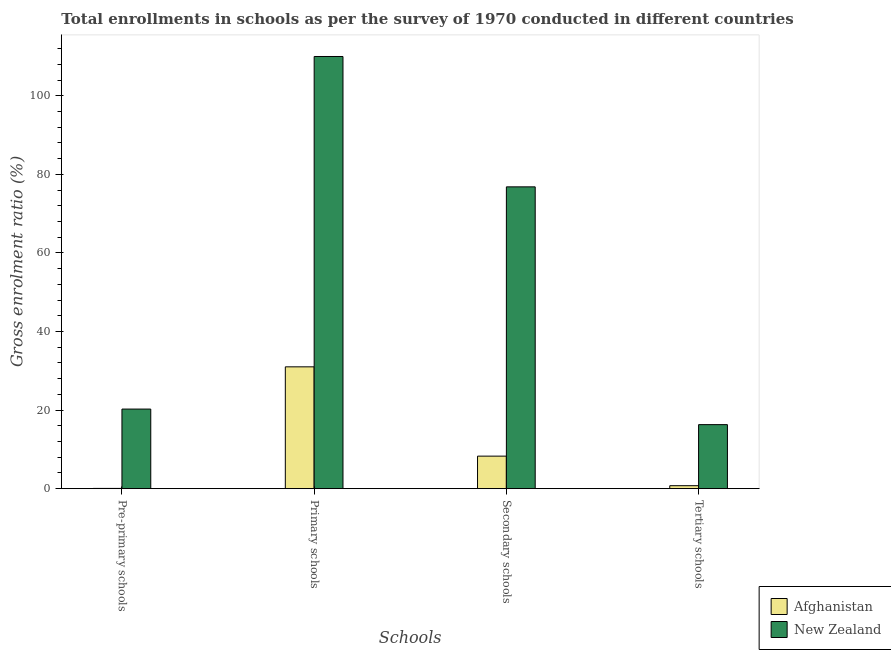How many groups of bars are there?
Make the answer very short. 4. How many bars are there on the 3rd tick from the right?
Provide a succinct answer. 2. What is the label of the 4th group of bars from the left?
Make the answer very short. Tertiary schools. What is the gross enrolment ratio in tertiary schools in Afghanistan?
Provide a succinct answer. 0.76. Across all countries, what is the maximum gross enrolment ratio in primary schools?
Your answer should be very brief. 110.01. Across all countries, what is the minimum gross enrolment ratio in pre-primary schools?
Provide a succinct answer. 0.07. In which country was the gross enrolment ratio in secondary schools maximum?
Keep it short and to the point. New Zealand. In which country was the gross enrolment ratio in secondary schools minimum?
Give a very brief answer. Afghanistan. What is the total gross enrolment ratio in tertiary schools in the graph?
Offer a very short reply. 17.06. What is the difference between the gross enrolment ratio in primary schools in New Zealand and that in Afghanistan?
Offer a very short reply. 79. What is the difference between the gross enrolment ratio in secondary schools in New Zealand and the gross enrolment ratio in pre-primary schools in Afghanistan?
Offer a very short reply. 76.76. What is the average gross enrolment ratio in pre-primary schools per country?
Your answer should be very brief. 10.17. What is the difference between the gross enrolment ratio in secondary schools and gross enrolment ratio in primary schools in Afghanistan?
Your answer should be compact. -22.73. In how many countries, is the gross enrolment ratio in tertiary schools greater than 48 %?
Make the answer very short. 0. What is the ratio of the gross enrolment ratio in pre-primary schools in Afghanistan to that in New Zealand?
Give a very brief answer. 0. Is the gross enrolment ratio in pre-primary schools in Afghanistan less than that in New Zealand?
Make the answer very short. Yes. What is the difference between the highest and the second highest gross enrolment ratio in primary schools?
Make the answer very short. 79. What is the difference between the highest and the lowest gross enrolment ratio in secondary schools?
Offer a terse response. 68.54. In how many countries, is the gross enrolment ratio in tertiary schools greater than the average gross enrolment ratio in tertiary schools taken over all countries?
Offer a terse response. 1. Is the sum of the gross enrolment ratio in tertiary schools in New Zealand and Afghanistan greater than the maximum gross enrolment ratio in primary schools across all countries?
Provide a short and direct response. No. Is it the case that in every country, the sum of the gross enrolment ratio in secondary schools and gross enrolment ratio in pre-primary schools is greater than the sum of gross enrolment ratio in primary schools and gross enrolment ratio in tertiary schools?
Your answer should be compact. No. What does the 1st bar from the left in Pre-primary schools represents?
Make the answer very short. Afghanistan. What does the 2nd bar from the right in Secondary schools represents?
Your answer should be very brief. Afghanistan. Is it the case that in every country, the sum of the gross enrolment ratio in pre-primary schools and gross enrolment ratio in primary schools is greater than the gross enrolment ratio in secondary schools?
Your response must be concise. Yes. How many bars are there?
Give a very brief answer. 8. How many countries are there in the graph?
Give a very brief answer. 2. What is the difference between two consecutive major ticks on the Y-axis?
Your response must be concise. 20. Are the values on the major ticks of Y-axis written in scientific E-notation?
Provide a short and direct response. No. How are the legend labels stacked?
Your answer should be compact. Vertical. What is the title of the graph?
Your answer should be very brief. Total enrollments in schools as per the survey of 1970 conducted in different countries. What is the label or title of the X-axis?
Offer a terse response. Schools. What is the Gross enrolment ratio (%) in Afghanistan in Pre-primary schools?
Offer a very short reply. 0.07. What is the Gross enrolment ratio (%) in New Zealand in Pre-primary schools?
Make the answer very short. 20.26. What is the Gross enrolment ratio (%) in Afghanistan in Primary schools?
Offer a terse response. 31.01. What is the Gross enrolment ratio (%) in New Zealand in Primary schools?
Offer a very short reply. 110.01. What is the Gross enrolment ratio (%) in Afghanistan in Secondary schools?
Provide a succinct answer. 8.29. What is the Gross enrolment ratio (%) of New Zealand in Secondary schools?
Keep it short and to the point. 76.83. What is the Gross enrolment ratio (%) of Afghanistan in Tertiary schools?
Provide a succinct answer. 0.76. What is the Gross enrolment ratio (%) in New Zealand in Tertiary schools?
Your response must be concise. 16.3. Across all Schools, what is the maximum Gross enrolment ratio (%) of Afghanistan?
Give a very brief answer. 31.01. Across all Schools, what is the maximum Gross enrolment ratio (%) in New Zealand?
Give a very brief answer. 110.01. Across all Schools, what is the minimum Gross enrolment ratio (%) of Afghanistan?
Offer a very short reply. 0.07. Across all Schools, what is the minimum Gross enrolment ratio (%) of New Zealand?
Ensure brevity in your answer.  16.3. What is the total Gross enrolment ratio (%) in Afghanistan in the graph?
Give a very brief answer. 40.13. What is the total Gross enrolment ratio (%) in New Zealand in the graph?
Your response must be concise. 223.4. What is the difference between the Gross enrolment ratio (%) in Afghanistan in Pre-primary schools and that in Primary schools?
Provide a succinct answer. -30.95. What is the difference between the Gross enrolment ratio (%) in New Zealand in Pre-primary schools and that in Primary schools?
Keep it short and to the point. -89.75. What is the difference between the Gross enrolment ratio (%) of Afghanistan in Pre-primary schools and that in Secondary schools?
Offer a very short reply. -8.22. What is the difference between the Gross enrolment ratio (%) of New Zealand in Pre-primary schools and that in Secondary schools?
Your answer should be compact. -56.56. What is the difference between the Gross enrolment ratio (%) in Afghanistan in Pre-primary schools and that in Tertiary schools?
Make the answer very short. -0.69. What is the difference between the Gross enrolment ratio (%) of New Zealand in Pre-primary schools and that in Tertiary schools?
Provide a short and direct response. 3.96. What is the difference between the Gross enrolment ratio (%) in Afghanistan in Primary schools and that in Secondary schools?
Your response must be concise. 22.73. What is the difference between the Gross enrolment ratio (%) in New Zealand in Primary schools and that in Secondary schools?
Your response must be concise. 33.18. What is the difference between the Gross enrolment ratio (%) of Afghanistan in Primary schools and that in Tertiary schools?
Offer a very short reply. 30.26. What is the difference between the Gross enrolment ratio (%) of New Zealand in Primary schools and that in Tertiary schools?
Provide a succinct answer. 93.71. What is the difference between the Gross enrolment ratio (%) in Afghanistan in Secondary schools and that in Tertiary schools?
Ensure brevity in your answer.  7.53. What is the difference between the Gross enrolment ratio (%) in New Zealand in Secondary schools and that in Tertiary schools?
Ensure brevity in your answer.  60.53. What is the difference between the Gross enrolment ratio (%) in Afghanistan in Pre-primary schools and the Gross enrolment ratio (%) in New Zealand in Primary schools?
Provide a succinct answer. -109.94. What is the difference between the Gross enrolment ratio (%) in Afghanistan in Pre-primary schools and the Gross enrolment ratio (%) in New Zealand in Secondary schools?
Ensure brevity in your answer.  -76.76. What is the difference between the Gross enrolment ratio (%) of Afghanistan in Pre-primary schools and the Gross enrolment ratio (%) of New Zealand in Tertiary schools?
Your response must be concise. -16.23. What is the difference between the Gross enrolment ratio (%) of Afghanistan in Primary schools and the Gross enrolment ratio (%) of New Zealand in Secondary schools?
Provide a succinct answer. -45.81. What is the difference between the Gross enrolment ratio (%) in Afghanistan in Primary schools and the Gross enrolment ratio (%) in New Zealand in Tertiary schools?
Provide a succinct answer. 14.71. What is the difference between the Gross enrolment ratio (%) of Afghanistan in Secondary schools and the Gross enrolment ratio (%) of New Zealand in Tertiary schools?
Your answer should be very brief. -8.02. What is the average Gross enrolment ratio (%) in Afghanistan per Schools?
Your answer should be compact. 10.03. What is the average Gross enrolment ratio (%) in New Zealand per Schools?
Keep it short and to the point. 55.85. What is the difference between the Gross enrolment ratio (%) in Afghanistan and Gross enrolment ratio (%) in New Zealand in Pre-primary schools?
Offer a terse response. -20.2. What is the difference between the Gross enrolment ratio (%) in Afghanistan and Gross enrolment ratio (%) in New Zealand in Primary schools?
Provide a succinct answer. -79. What is the difference between the Gross enrolment ratio (%) in Afghanistan and Gross enrolment ratio (%) in New Zealand in Secondary schools?
Ensure brevity in your answer.  -68.54. What is the difference between the Gross enrolment ratio (%) of Afghanistan and Gross enrolment ratio (%) of New Zealand in Tertiary schools?
Make the answer very short. -15.54. What is the ratio of the Gross enrolment ratio (%) of Afghanistan in Pre-primary schools to that in Primary schools?
Ensure brevity in your answer.  0. What is the ratio of the Gross enrolment ratio (%) of New Zealand in Pre-primary schools to that in Primary schools?
Offer a very short reply. 0.18. What is the ratio of the Gross enrolment ratio (%) of Afghanistan in Pre-primary schools to that in Secondary schools?
Your answer should be very brief. 0.01. What is the ratio of the Gross enrolment ratio (%) in New Zealand in Pre-primary schools to that in Secondary schools?
Offer a terse response. 0.26. What is the ratio of the Gross enrolment ratio (%) of Afghanistan in Pre-primary schools to that in Tertiary schools?
Give a very brief answer. 0.09. What is the ratio of the Gross enrolment ratio (%) in New Zealand in Pre-primary schools to that in Tertiary schools?
Give a very brief answer. 1.24. What is the ratio of the Gross enrolment ratio (%) in Afghanistan in Primary schools to that in Secondary schools?
Offer a very short reply. 3.74. What is the ratio of the Gross enrolment ratio (%) in New Zealand in Primary schools to that in Secondary schools?
Provide a succinct answer. 1.43. What is the ratio of the Gross enrolment ratio (%) in Afghanistan in Primary schools to that in Tertiary schools?
Your answer should be very brief. 40.94. What is the ratio of the Gross enrolment ratio (%) of New Zealand in Primary schools to that in Tertiary schools?
Offer a very short reply. 6.75. What is the ratio of the Gross enrolment ratio (%) of Afghanistan in Secondary schools to that in Tertiary schools?
Offer a very short reply. 10.94. What is the ratio of the Gross enrolment ratio (%) of New Zealand in Secondary schools to that in Tertiary schools?
Your answer should be compact. 4.71. What is the difference between the highest and the second highest Gross enrolment ratio (%) of Afghanistan?
Provide a succinct answer. 22.73. What is the difference between the highest and the second highest Gross enrolment ratio (%) of New Zealand?
Keep it short and to the point. 33.18. What is the difference between the highest and the lowest Gross enrolment ratio (%) of Afghanistan?
Provide a short and direct response. 30.95. What is the difference between the highest and the lowest Gross enrolment ratio (%) in New Zealand?
Provide a short and direct response. 93.71. 